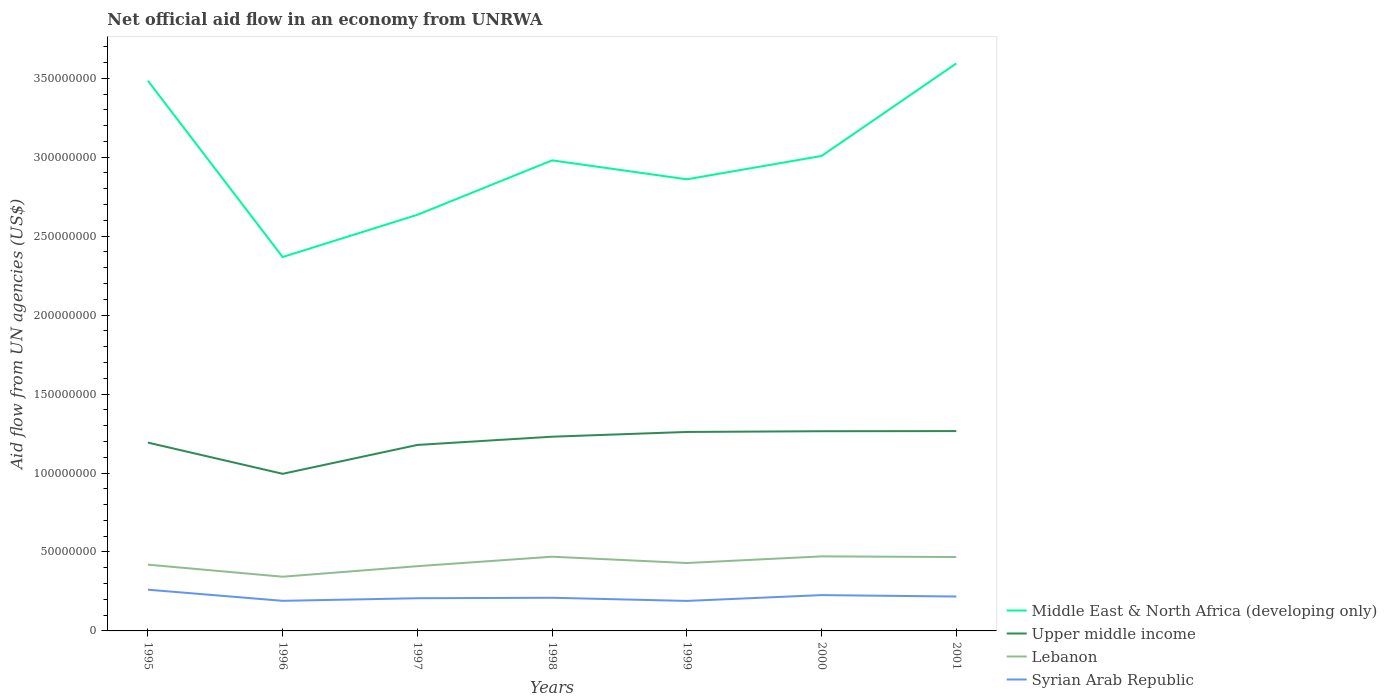How many different coloured lines are there?
Make the answer very short. 4. Across all years, what is the maximum net official aid flow in Syrian Arab Republic?
Make the answer very short. 1.90e+07. What is the total net official aid flow in Middle East & North Africa (developing only) in the graph?
Provide a short and direct response. -6.14e+07. What is the difference between the highest and the second highest net official aid flow in Lebanon?
Offer a very short reply. 1.29e+07. How many lines are there?
Provide a short and direct response. 4. Are the values on the major ticks of Y-axis written in scientific E-notation?
Ensure brevity in your answer.  No. Does the graph contain any zero values?
Give a very brief answer. No. How are the legend labels stacked?
Make the answer very short. Vertical. What is the title of the graph?
Your answer should be very brief. Net official aid flow in an economy from UNRWA. Does "Nepal" appear as one of the legend labels in the graph?
Your answer should be very brief. No. What is the label or title of the Y-axis?
Offer a terse response. Aid flow from UN agencies (US$). What is the Aid flow from UN agencies (US$) in Middle East & North Africa (developing only) in 1995?
Your answer should be very brief. 3.48e+08. What is the Aid flow from UN agencies (US$) of Upper middle income in 1995?
Ensure brevity in your answer.  1.19e+08. What is the Aid flow from UN agencies (US$) of Lebanon in 1995?
Offer a terse response. 4.20e+07. What is the Aid flow from UN agencies (US$) in Syrian Arab Republic in 1995?
Offer a terse response. 2.61e+07. What is the Aid flow from UN agencies (US$) of Middle East & North Africa (developing only) in 1996?
Your response must be concise. 2.37e+08. What is the Aid flow from UN agencies (US$) in Upper middle income in 1996?
Provide a succinct answer. 9.95e+07. What is the Aid flow from UN agencies (US$) of Lebanon in 1996?
Your answer should be compact. 3.43e+07. What is the Aid flow from UN agencies (US$) in Syrian Arab Republic in 1996?
Your response must be concise. 1.91e+07. What is the Aid flow from UN agencies (US$) of Middle East & North Africa (developing only) in 1997?
Your response must be concise. 2.64e+08. What is the Aid flow from UN agencies (US$) in Upper middle income in 1997?
Offer a very short reply. 1.18e+08. What is the Aid flow from UN agencies (US$) in Lebanon in 1997?
Provide a succinct answer. 4.10e+07. What is the Aid flow from UN agencies (US$) of Syrian Arab Republic in 1997?
Give a very brief answer. 2.07e+07. What is the Aid flow from UN agencies (US$) in Middle East & North Africa (developing only) in 1998?
Your response must be concise. 2.98e+08. What is the Aid flow from UN agencies (US$) of Upper middle income in 1998?
Make the answer very short. 1.23e+08. What is the Aid flow from UN agencies (US$) in Lebanon in 1998?
Your answer should be very brief. 4.70e+07. What is the Aid flow from UN agencies (US$) of Syrian Arab Republic in 1998?
Ensure brevity in your answer.  2.10e+07. What is the Aid flow from UN agencies (US$) of Middle East & North Africa (developing only) in 1999?
Give a very brief answer. 2.86e+08. What is the Aid flow from UN agencies (US$) in Upper middle income in 1999?
Offer a terse response. 1.26e+08. What is the Aid flow from UN agencies (US$) of Lebanon in 1999?
Make the answer very short. 4.30e+07. What is the Aid flow from UN agencies (US$) of Syrian Arab Republic in 1999?
Offer a terse response. 1.90e+07. What is the Aid flow from UN agencies (US$) of Middle East & North Africa (developing only) in 2000?
Your response must be concise. 3.01e+08. What is the Aid flow from UN agencies (US$) of Upper middle income in 2000?
Ensure brevity in your answer.  1.26e+08. What is the Aid flow from UN agencies (US$) in Lebanon in 2000?
Your answer should be compact. 4.72e+07. What is the Aid flow from UN agencies (US$) in Syrian Arab Republic in 2000?
Give a very brief answer. 2.27e+07. What is the Aid flow from UN agencies (US$) of Middle East & North Africa (developing only) in 2001?
Ensure brevity in your answer.  3.59e+08. What is the Aid flow from UN agencies (US$) of Upper middle income in 2001?
Your answer should be compact. 1.27e+08. What is the Aid flow from UN agencies (US$) of Lebanon in 2001?
Make the answer very short. 4.68e+07. What is the Aid flow from UN agencies (US$) in Syrian Arab Republic in 2001?
Offer a terse response. 2.18e+07. Across all years, what is the maximum Aid flow from UN agencies (US$) of Middle East & North Africa (developing only)?
Your response must be concise. 3.59e+08. Across all years, what is the maximum Aid flow from UN agencies (US$) in Upper middle income?
Make the answer very short. 1.27e+08. Across all years, what is the maximum Aid flow from UN agencies (US$) of Lebanon?
Provide a succinct answer. 4.72e+07. Across all years, what is the maximum Aid flow from UN agencies (US$) in Syrian Arab Republic?
Your response must be concise. 2.61e+07. Across all years, what is the minimum Aid flow from UN agencies (US$) in Middle East & North Africa (developing only)?
Offer a terse response. 2.37e+08. Across all years, what is the minimum Aid flow from UN agencies (US$) in Upper middle income?
Offer a very short reply. 9.95e+07. Across all years, what is the minimum Aid flow from UN agencies (US$) in Lebanon?
Your answer should be compact. 3.43e+07. Across all years, what is the minimum Aid flow from UN agencies (US$) of Syrian Arab Republic?
Provide a short and direct response. 1.90e+07. What is the total Aid flow from UN agencies (US$) in Middle East & North Africa (developing only) in the graph?
Your answer should be very brief. 2.09e+09. What is the total Aid flow from UN agencies (US$) in Upper middle income in the graph?
Your response must be concise. 8.39e+08. What is the total Aid flow from UN agencies (US$) of Lebanon in the graph?
Provide a short and direct response. 3.01e+08. What is the total Aid flow from UN agencies (US$) in Syrian Arab Republic in the graph?
Your answer should be very brief. 1.50e+08. What is the difference between the Aid flow from UN agencies (US$) in Middle East & North Africa (developing only) in 1995 and that in 1996?
Your answer should be very brief. 1.12e+08. What is the difference between the Aid flow from UN agencies (US$) of Upper middle income in 1995 and that in 1996?
Your answer should be very brief. 1.98e+07. What is the difference between the Aid flow from UN agencies (US$) of Lebanon in 1995 and that in 1996?
Your response must be concise. 7.63e+06. What is the difference between the Aid flow from UN agencies (US$) of Syrian Arab Republic in 1995 and that in 1996?
Provide a succinct answer. 7.05e+06. What is the difference between the Aid flow from UN agencies (US$) in Middle East & North Africa (developing only) in 1995 and that in 1997?
Offer a very short reply. 8.49e+07. What is the difference between the Aid flow from UN agencies (US$) of Upper middle income in 1995 and that in 1997?
Keep it short and to the point. 1.48e+06. What is the difference between the Aid flow from UN agencies (US$) in Lebanon in 1995 and that in 1997?
Provide a succinct answer. 9.60e+05. What is the difference between the Aid flow from UN agencies (US$) in Syrian Arab Republic in 1995 and that in 1997?
Provide a short and direct response. 5.41e+06. What is the difference between the Aid flow from UN agencies (US$) of Middle East & North Africa (developing only) in 1995 and that in 1998?
Your answer should be compact. 5.04e+07. What is the difference between the Aid flow from UN agencies (US$) in Upper middle income in 1995 and that in 1998?
Make the answer very short. -3.74e+06. What is the difference between the Aid flow from UN agencies (US$) of Lebanon in 1995 and that in 1998?
Provide a short and direct response. -5.04e+06. What is the difference between the Aid flow from UN agencies (US$) in Syrian Arab Republic in 1995 and that in 1998?
Your answer should be very brief. 5.11e+06. What is the difference between the Aid flow from UN agencies (US$) in Middle East & North Africa (developing only) in 1995 and that in 1999?
Your answer should be compact. 6.24e+07. What is the difference between the Aid flow from UN agencies (US$) of Upper middle income in 1995 and that in 1999?
Keep it short and to the point. -6.74e+06. What is the difference between the Aid flow from UN agencies (US$) in Lebanon in 1995 and that in 1999?
Your answer should be compact. -1.04e+06. What is the difference between the Aid flow from UN agencies (US$) of Syrian Arab Republic in 1995 and that in 1999?
Provide a short and direct response. 7.11e+06. What is the difference between the Aid flow from UN agencies (US$) in Middle East & North Africa (developing only) in 1995 and that in 2000?
Provide a short and direct response. 4.76e+07. What is the difference between the Aid flow from UN agencies (US$) of Upper middle income in 1995 and that in 2000?
Ensure brevity in your answer.  -7.21e+06. What is the difference between the Aid flow from UN agencies (US$) of Lebanon in 1995 and that in 2000?
Provide a short and direct response. -5.25e+06. What is the difference between the Aid flow from UN agencies (US$) in Syrian Arab Republic in 1995 and that in 2000?
Provide a succinct answer. 3.43e+06. What is the difference between the Aid flow from UN agencies (US$) of Middle East & North Africa (developing only) in 1995 and that in 2001?
Offer a very short reply. -1.10e+07. What is the difference between the Aid flow from UN agencies (US$) of Upper middle income in 1995 and that in 2001?
Keep it short and to the point. -7.30e+06. What is the difference between the Aid flow from UN agencies (US$) of Lebanon in 1995 and that in 2001?
Provide a short and direct response. -4.83e+06. What is the difference between the Aid flow from UN agencies (US$) in Syrian Arab Republic in 1995 and that in 2001?
Offer a very short reply. 4.33e+06. What is the difference between the Aid flow from UN agencies (US$) in Middle East & North Africa (developing only) in 1996 and that in 1997?
Provide a succinct answer. -2.67e+07. What is the difference between the Aid flow from UN agencies (US$) in Upper middle income in 1996 and that in 1997?
Your response must be concise. -1.83e+07. What is the difference between the Aid flow from UN agencies (US$) in Lebanon in 1996 and that in 1997?
Your response must be concise. -6.67e+06. What is the difference between the Aid flow from UN agencies (US$) of Syrian Arab Republic in 1996 and that in 1997?
Your answer should be compact. -1.64e+06. What is the difference between the Aid flow from UN agencies (US$) of Middle East & North Africa (developing only) in 1996 and that in 1998?
Your answer should be very brief. -6.12e+07. What is the difference between the Aid flow from UN agencies (US$) in Upper middle income in 1996 and that in 1998?
Provide a succinct answer. -2.35e+07. What is the difference between the Aid flow from UN agencies (US$) of Lebanon in 1996 and that in 1998?
Give a very brief answer. -1.27e+07. What is the difference between the Aid flow from UN agencies (US$) in Syrian Arab Republic in 1996 and that in 1998?
Provide a succinct answer. -1.94e+06. What is the difference between the Aid flow from UN agencies (US$) in Middle East & North Africa (developing only) in 1996 and that in 1999?
Offer a very short reply. -4.92e+07. What is the difference between the Aid flow from UN agencies (US$) in Upper middle income in 1996 and that in 1999?
Keep it short and to the point. -2.65e+07. What is the difference between the Aid flow from UN agencies (US$) of Lebanon in 1996 and that in 1999?
Offer a terse response. -8.67e+06. What is the difference between the Aid flow from UN agencies (US$) in Middle East & North Africa (developing only) in 1996 and that in 2000?
Your answer should be compact. -6.40e+07. What is the difference between the Aid flow from UN agencies (US$) in Upper middle income in 1996 and that in 2000?
Offer a terse response. -2.70e+07. What is the difference between the Aid flow from UN agencies (US$) in Lebanon in 1996 and that in 2000?
Ensure brevity in your answer.  -1.29e+07. What is the difference between the Aid flow from UN agencies (US$) of Syrian Arab Republic in 1996 and that in 2000?
Your response must be concise. -3.62e+06. What is the difference between the Aid flow from UN agencies (US$) in Middle East & North Africa (developing only) in 1996 and that in 2001?
Your response must be concise. -1.23e+08. What is the difference between the Aid flow from UN agencies (US$) in Upper middle income in 1996 and that in 2001?
Provide a succinct answer. -2.71e+07. What is the difference between the Aid flow from UN agencies (US$) in Lebanon in 1996 and that in 2001?
Your answer should be very brief. -1.25e+07. What is the difference between the Aid flow from UN agencies (US$) in Syrian Arab Republic in 1996 and that in 2001?
Provide a short and direct response. -2.72e+06. What is the difference between the Aid flow from UN agencies (US$) in Middle East & North Africa (developing only) in 1997 and that in 1998?
Your response must be concise. -3.45e+07. What is the difference between the Aid flow from UN agencies (US$) in Upper middle income in 1997 and that in 1998?
Provide a succinct answer. -5.22e+06. What is the difference between the Aid flow from UN agencies (US$) in Lebanon in 1997 and that in 1998?
Make the answer very short. -6.00e+06. What is the difference between the Aid flow from UN agencies (US$) of Syrian Arab Republic in 1997 and that in 1998?
Keep it short and to the point. -3.00e+05. What is the difference between the Aid flow from UN agencies (US$) of Middle East & North Africa (developing only) in 1997 and that in 1999?
Provide a succinct answer. -2.25e+07. What is the difference between the Aid flow from UN agencies (US$) of Upper middle income in 1997 and that in 1999?
Your answer should be very brief. -8.22e+06. What is the difference between the Aid flow from UN agencies (US$) of Syrian Arab Republic in 1997 and that in 1999?
Your response must be concise. 1.70e+06. What is the difference between the Aid flow from UN agencies (US$) of Middle East & North Africa (developing only) in 1997 and that in 2000?
Provide a short and direct response. -3.73e+07. What is the difference between the Aid flow from UN agencies (US$) in Upper middle income in 1997 and that in 2000?
Give a very brief answer. -8.69e+06. What is the difference between the Aid flow from UN agencies (US$) in Lebanon in 1997 and that in 2000?
Offer a terse response. -6.21e+06. What is the difference between the Aid flow from UN agencies (US$) in Syrian Arab Republic in 1997 and that in 2000?
Keep it short and to the point. -1.98e+06. What is the difference between the Aid flow from UN agencies (US$) of Middle East & North Africa (developing only) in 1997 and that in 2001?
Provide a succinct answer. -9.58e+07. What is the difference between the Aid flow from UN agencies (US$) in Upper middle income in 1997 and that in 2001?
Keep it short and to the point. -8.78e+06. What is the difference between the Aid flow from UN agencies (US$) of Lebanon in 1997 and that in 2001?
Give a very brief answer. -5.79e+06. What is the difference between the Aid flow from UN agencies (US$) of Syrian Arab Republic in 1997 and that in 2001?
Your answer should be compact. -1.08e+06. What is the difference between the Aid flow from UN agencies (US$) in Lebanon in 1998 and that in 1999?
Provide a succinct answer. 4.00e+06. What is the difference between the Aid flow from UN agencies (US$) in Syrian Arab Republic in 1998 and that in 1999?
Give a very brief answer. 2.00e+06. What is the difference between the Aid flow from UN agencies (US$) of Middle East & North Africa (developing only) in 1998 and that in 2000?
Keep it short and to the point. -2.78e+06. What is the difference between the Aid flow from UN agencies (US$) of Upper middle income in 1998 and that in 2000?
Offer a very short reply. -3.47e+06. What is the difference between the Aid flow from UN agencies (US$) in Lebanon in 1998 and that in 2000?
Your answer should be very brief. -2.10e+05. What is the difference between the Aid flow from UN agencies (US$) of Syrian Arab Republic in 1998 and that in 2000?
Keep it short and to the point. -1.68e+06. What is the difference between the Aid flow from UN agencies (US$) of Middle East & North Africa (developing only) in 1998 and that in 2001?
Ensure brevity in your answer.  -6.14e+07. What is the difference between the Aid flow from UN agencies (US$) of Upper middle income in 1998 and that in 2001?
Offer a terse response. -3.56e+06. What is the difference between the Aid flow from UN agencies (US$) in Lebanon in 1998 and that in 2001?
Your response must be concise. 2.10e+05. What is the difference between the Aid flow from UN agencies (US$) in Syrian Arab Republic in 1998 and that in 2001?
Offer a very short reply. -7.80e+05. What is the difference between the Aid flow from UN agencies (US$) in Middle East & North Africa (developing only) in 1999 and that in 2000?
Make the answer very short. -1.48e+07. What is the difference between the Aid flow from UN agencies (US$) in Upper middle income in 1999 and that in 2000?
Offer a terse response. -4.70e+05. What is the difference between the Aid flow from UN agencies (US$) of Lebanon in 1999 and that in 2000?
Your answer should be compact. -4.21e+06. What is the difference between the Aid flow from UN agencies (US$) in Syrian Arab Republic in 1999 and that in 2000?
Give a very brief answer. -3.68e+06. What is the difference between the Aid flow from UN agencies (US$) in Middle East & North Africa (developing only) in 1999 and that in 2001?
Your answer should be compact. -7.34e+07. What is the difference between the Aid flow from UN agencies (US$) in Upper middle income in 1999 and that in 2001?
Provide a short and direct response. -5.60e+05. What is the difference between the Aid flow from UN agencies (US$) of Lebanon in 1999 and that in 2001?
Your response must be concise. -3.79e+06. What is the difference between the Aid flow from UN agencies (US$) in Syrian Arab Republic in 1999 and that in 2001?
Make the answer very short. -2.78e+06. What is the difference between the Aid flow from UN agencies (US$) of Middle East & North Africa (developing only) in 2000 and that in 2001?
Offer a terse response. -5.86e+07. What is the difference between the Aid flow from UN agencies (US$) in Syrian Arab Republic in 2000 and that in 2001?
Provide a succinct answer. 9.00e+05. What is the difference between the Aid flow from UN agencies (US$) of Middle East & North Africa (developing only) in 1995 and the Aid flow from UN agencies (US$) of Upper middle income in 1996?
Your answer should be compact. 2.49e+08. What is the difference between the Aid flow from UN agencies (US$) in Middle East & North Africa (developing only) in 1995 and the Aid flow from UN agencies (US$) in Lebanon in 1996?
Make the answer very short. 3.14e+08. What is the difference between the Aid flow from UN agencies (US$) of Middle East & North Africa (developing only) in 1995 and the Aid flow from UN agencies (US$) of Syrian Arab Republic in 1996?
Your response must be concise. 3.29e+08. What is the difference between the Aid flow from UN agencies (US$) of Upper middle income in 1995 and the Aid flow from UN agencies (US$) of Lebanon in 1996?
Make the answer very short. 8.49e+07. What is the difference between the Aid flow from UN agencies (US$) in Upper middle income in 1995 and the Aid flow from UN agencies (US$) in Syrian Arab Republic in 1996?
Offer a very short reply. 1.00e+08. What is the difference between the Aid flow from UN agencies (US$) of Lebanon in 1995 and the Aid flow from UN agencies (US$) of Syrian Arab Republic in 1996?
Ensure brevity in your answer.  2.29e+07. What is the difference between the Aid flow from UN agencies (US$) in Middle East & North Africa (developing only) in 1995 and the Aid flow from UN agencies (US$) in Upper middle income in 1997?
Provide a succinct answer. 2.31e+08. What is the difference between the Aid flow from UN agencies (US$) of Middle East & North Africa (developing only) in 1995 and the Aid flow from UN agencies (US$) of Lebanon in 1997?
Offer a terse response. 3.07e+08. What is the difference between the Aid flow from UN agencies (US$) of Middle East & North Africa (developing only) in 1995 and the Aid flow from UN agencies (US$) of Syrian Arab Republic in 1997?
Your response must be concise. 3.28e+08. What is the difference between the Aid flow from UN agencies (US$) in Upper middle income in 1995 and the Aid flow from UN agencies (US$) in Lebanon in 1997?
Provide a succinct answer. 7.83e+07. What is the difference between the Aid flow from UN agencies (US$) of Upper middle income in 1995 and the Aid flow from UN agencies (US$) of Syrian Arab Republic in 1997?
Your answer should be very brief. 9.86e+07. What is the difference between the Aid flow from UN agencies (US$) in Lebanon in 1995 and the Aid flow from UN agencies (US$) in Syrian Arab Republic in 1997?
Offer a very short reply. 2.13e+07. What is the difference between the Aid flow from UN agencies (US$) of Middle East & North Africa (developing only) in 1995 and the Aid flow from UN agencies (US$) of Upper middle income in 1998?
Your answer should be very brief. 2.25e+08. What is the difference between the Aid flow from UN agencies (US$) of Middle East & North Africa (developing only) in 1995 and the Aid flow from UN agencies (US$) of Lebanon in 1998?
Your response must be concise. 3.01e+08. What is the difference between the Aid flow from UN agencies (US$) in Middle East & North Africa (developing only) in 1995 and the Aid flow from UN agencies (US$) in Syrian Arab Republic in 1998?
Keep it short and to the point. 3.27e+08. What is the difference between the Aid flow from UN agencies (US$) in Upper middle income in 1995 and the Aid flow from UN agencies (US$) in Lebanon in 1998?
Keep it short and to the point. 7.23e+07. What is the difference between the Aid flow from UN agencies (US$) in Upper middle income in 1995 and the Aid flow from UN agencies (US$) in Syrian Arab Republic in 1998?
Ensure brevity in your answer.  9.83e+07. What is the difference between the Aid flow from UN agencies (US$) in Lebanon in 1995 and the Aid flow from UN agencies (US$) in Syrian Arab Republic in 1998?
Offer a terse response. 2.10e+07. What is the difference between the Aid flow from UN agencies (US$) in Middle East & North Africa (developing only) in 1995 and the Aid flow from UN agencies (US$) in Upper middle income in 1999?
Provide a succinct answer. 2.22e+08. What is the difference between the Aid flow from UN agencies (US$) in Middle East & North Africa (developing only) in 1995 and the Aid flow from UN agencies (US$) in Lebanon in 1999?
Your response must be concise. 3.05e+08. What is the difference between the Aid flow from UN agencies (US$) of Middle East & North Africa (developing only) in 1995 and the Aid flow from UN agencies (US$) of Syrian Arab Republic in 1999?
Provide a short and direct response. 3.29e+08. What is the difference between the Aid flow from UN agencies (US$) of Upper middle income in 1995 and the Aid flow from UN agencies (US$) of Lebanon in 1999?
Give a very brief answer. 7.63e+07. What is the difference between the Aid flow from UN agencies (US$) in Upper middle income in 1995 and the Aid flow from UN agencies (US$) in Syrian Arab Republic in 1999?
Provide a short and direct response. 1.00e+08. What is the difference between the Aid flow from UN agencies (US$) of Lebanon in 1995 and the Aid flow from UN agencies (US$) of Syrian Arab Republic in 1999?
Your answer should be compact. 2.30e+07. What is the difference between the Aid flow from UN agencies (US$) of Middle East & North Africa (developing only) in 1995 and the Aid flow from UN agencies (US$) of Upper middle income in 2000?
Give a very brief answer. 2.22e+08. What is the difference between the Aid flow from UN agencies (US$) in Middle East & North Africa (developing only) in 1995 and the Aid flow from UN agencies (US$) in Lebanon in 2000?
Offer a terse response. 3.01e+08. What is the difference between the Aid flow from UN agencies (US$) of Middle East & North Africa (developing only) in 1995 and the Aid flow from UN agencies (US$) of Syrian Arab Republic in 2000?
Ensure brevity in your answer.  3.26e+08. What is the difference between the Aid flow from UN agencies (US$) in Upper middle income in 1995 and the Aid flow from UN agencies (US$) in Lebanon in 2000?
Offer a terse response. 7.20e+07. What is the difference between the Aid flow from UN agencies (US$) in Upper middle income in 1995 and the Aid flow from UN agencies (US$) in Syrian Arab Republic in 2000?
Your answer should be very brief. 9.66e+07. What is the difference between the Aid flow from UN agencies (US$) in Lebanon in 1995 and the Aid flow from UN agencies (US$) in Syrian Arab Republic in 2000?
Provide a succinct answer. 1.93e+07. What is the difference between the Aid flow from UN agencies (US$) of Middle East & North Africa (developing only) in 1995 and the Aid flow from UN agencies (US$) of Upper middle income in 2001?
Provide a succinct answer. 2.22e+08. What is the difference between the Aid flow from UN agencies (US$) of Middle East & North Africa (developing only) in 1995 and the Aid flow from UN agencies (US$) of Lebanon in 2001?
Ensure brevity in your answer.  3.02e+08. What is the difference between the Aid flow from UN agencies (US$) in Middle East & North Africa (developing only) in 1995 and the Aid flow from UN agencies (US$) in Syrian Arab Republic in 2001?
Provide a succinct answer. 3.27e+08. What is the difference between the Aid flow from UN agencies (US$) of Upper middle income in 1995 and the Aid flow from UN agencies (US$) of Lebanon in 2001?
Make the answer very short. 7.25e+07. What is the difference between the Aid flow from UN agencies (US$) of Upper middle income in 1995 and the Aid flow from UN agencies (US$) of Syrian Arab Republic in 2001?
Your answer should be very brief. 9.75e+07. What is the difference between the Aid flow from UN agencies (US$) in Lebanon in 1995 and the Aid flow from UN agencies (US$) in Syrian Arab Republic in 2001?
Provide a succinct answer. 2.02e+07. What is the difference between the Aid flow from UN agencies (US$) in Middle East & North Africa (developing only) in 1996 and the Aid flow from UN agencies (US$) in Upper middle income in 1997?
Keep it short and to the point. 1.19e+08. What is the difference between the Aid flow from UN agencies (US$) in Middle East & North Africa (developing only) in 1996 and the Aid flow from UN agencies (US$) in Lebanon in 1997?
Provide a short and direct response. 1.96e+08. What is the difference between the Aid flow from UN agencies (US$) of Middle East & North Africa (developing only) in 1996 and the Aid flow from UN agencies (US$) of Syrian Arab Republic in 1997?
Your answer should be compact. 2.16e+08. What is the difference between the Aid flow from UN agencies (US$) in Upper middle income in 1996 and the Aid flow from UN agencies (US$) in Lebanon in 1997?
Provide a succinct answer. 5.85e+07. What is the difference between the Aid flow from UN agencies (US$) of Upper middle income in 1996 and the Aid flow from UN agencies (US$) of Syrian Arab Republic in 1997?
Give a very brief answer. 7.88e+07. What is the difference between the Aid flow from UN agencies (US$) in Lebanon in 1996 and the Aid flow from UN agencies (US$) in Syrian Arab Republic in 1997?
Offer a terse response. 1.36e+07. What is the difference between the Aid flow from UN agencies (US$) of Middle East & North Africa (developing only) in 1996 and the Aid flow from UN agencies (US$) of Upper middle income in 1998?
Keep it short and to the point. 1.14e+08. What is the difference between the Aid flow from UN agencies (US$) of Middle East & North Africa (developing only) in 1996 and the Aid flow from UN agencies (US$) of Lebanon in 1998?
Offer a terse response. 1.90e+08. What is the difference between the Aid flow from UN agencies (US$) of Middle East & North Africa (developing only) in 1996 and the Aid flow from UN agencies (US$) of Syrian Arab Republic in 1998?
Your answer should be compact. 2.16e+08. What is the difference between the Aid flow from UN agencies (US$) of Upper middle income in 1996 and the Aid flow from UN agencies (US$) of Lebanon in 1998?
Ensure brevity in your answer.  5.25e+07. What is the difference between the Aid flow from UN agencies (US$) of Upper middle income in 1996 and the Aid flow from UN agencies (US$) of Syrian Arab Republic in 1998?
Your answer should be very brief. 7.85e+07. What is the difference between the Aid flow from UN agencies (US$) in Lebanon in 1996 and the Aid flow from UN agencies (US$) in Syrian Arab Republic in 1998?
Your response must be concise. 1.33e+07. What is the difference between the Aid flow from UN agencies (US$) of Middle East & North Africa (developing only) in 1996 and the Aid flow from UN agencies (US$) of Upper middle income in 1999?
Keep it short and to the point. 1.11e+08. What is the difference between the Aid flow from UN agencies (US$) of Middle East & North Africa (developing only) in 1996 and the Aid flow from UN agencies (US$) of Lebanon in 1999?
Your answer should be compact. 1.94e+08. What is the difference between the Aid flow from UN agencies (US$) in Middle East & North Africa (developing only) in 1996 and the Aid flow from UN agencies (US$) in Syrian Arab Republic in 1999?
Provide a succinct answer. 2.18e+08. What is the difference between the Aid flow from UN agencies (US$) in Upper middle income in 1996 and the Aid flow from UN agencies (US$) in Lebanon in 1999?
Keep it short and to the point. 5.65e+07. What is the difference between the Aid flow from UN agencies (US$) in Upper middle income in 1996 and the Aid flow from UN agencies (US$) in Syrian Arab Republic in 1999?
Give a very brief answer. 8.05e+07. What is the difference between the Aid flow from UN agencies (US$) of Lebanon in 1996 and the Aid flow from UN agencies (US$) of Syrian Arab Republic in 1999?
Ensure brevity in your answer.  1.53e+07. What is the difference between the Aid flow from UN agencies (US$) in Middle East & North Africa (developing only) in 1996 and the Aid flow from UN agencies (US$) in Upper middle income in 2000?
Give a very brief answer. 1.10e+08. What is the difference between the Aid flow from UN agencies (US$) of Middle East & North Africa (developing only) in 1996 and the Aid flow from UN agencies (US$) of Lebanon in 2000?
Keep it short and to the point. 1.90e+08. What is the difference between the Aid flow from UN agencies (US$) of Middle East & North Africa (developing only) in 1996 and the Aid flow from UN agencies (US$) of Syrian Arab Republic in 2000?
Your response must be concise. 2.14e+08. What is the difference between the Aid flow from UN agencies (US$) of Upper middle income in 1996 and the Aid flow from UN agencies (US$) of Lebanon in 2000?
Your answer should be very brief. 5.23e+07. What is the difference between the Aid flow from UN agencies (US$) in Upper middle income in 1996 and the Aid flow from UN agencies (US$) in Syrian Arab Republic in 2000?
Your answer should be compact. 7.68e+07. What is the difference between the Aid flow from UN agencies (US$) of Lebanon in 1996 and the Aid flow from UN agencies (US$) of Syrian Arab Republic in 2000?
Provide a succinct answer. 1.16e+07. What is the difference between the Aid flow from UN agencies (US$) in Middle East & North Africa (developing only) in 1996 and the Aid flow from UN agencies (US$) in Upper middle income in 2001?
Your response must be concise. 1.10e+08. What is the difference between the Aid flow from UN agencies (US$) of Middle East & North Africa (developing only) in 1996 and the Aid flow from UN agencies (US$) of Lebanon in 2001?
Offer a terse response. 1.90e+08. What is the difference between the Aid flow from UN agencies (US$) of Middle East & North Africa (developing only) in 1996 and the Aid flow from UN agencies (US$) of Syrian Arab Republic in 2001?
Keep it short and to the point. 2.15e+08. What is the difference between the Aid flow from UN agencies (US$) in Upper middle income in 1996 and the Aid flow from UN agencies (US$) in Lebanon in 2001?
Your response must be concise. 5.27e+07. What is the difference between the Aid flow from UN agencies (US$) in Upper middle income in 1996 and the Aid flow from UN agencies (US$) in Syrian Arab Republic in 2001?
Offer a very short reply. 7.77e+07. What is the difference between the Aid flow from UN agencies (US$) in Lebanon in 1996 and the Aid flow from UN agencies (US$) in Syrian Arab Republic in 2001?
Provide a succinct answer. 1.26e+07. What is the difference between the Aid flow from UN agencies (US$) in Middle East & North Africa (developing only) in 1997 and the Aid flow from UN agencies (US$) in Upper middle income in 1998?
Your answer should be compact. 1.41e+08. What is the difference between the Aid flow from UN agencies (US$) of Middle East & North Africa (developing only) in 1997 and the Aid flow from UN agencies (US$) of Lebanon in 1998?
Give a very brief answer. 2.17e+08. What is the difference between the Aid flow from UN agencies (US$) of Middle East & North Africa (developing only) in 1997 and the Aid flow from UN agencies (US$) of Syrian Arab Republic in 1998?
Your answer should be compact. 2.43e+08. What is the difference between the Aid flow from UN agencies (US$) in Upper middle income in 1997 and the Aid flow from UN agencies (US$) in Lebanon in 1998?
Give a very brief answer. 7.08e+07. What is the difference between the Aid flow from UN agencies (US$) in Upper middle income in 1997 and the Aid flow from UN agencies (US$) in Syrian Arab Republic in 1998?
Your answer should be compact. 9.68e+07. What is the difference between the Aid flow from UN agencies (US$) of Lebanon in 1997 and the Aid flow from UN agencies (US$) of Syrian Arab Republic in 1998?
Your answer should be compact. 2.00e+07. What is the difference between the Aid flow from UN agencies (US$) of Middle East & North Africa (developing only) in 1997 and the Aid flow from UN agencies (US$) of Upper middle income in 1999?
Make the answer very short. 1.38e+08. What is the difference between the Aid flow from UN agencies (US$) of Middle East & North Africa (developing only) in 1997 and the Aid flow from UN agencies (US$) of Lebanon in 1999?
Ensure brevity in your answer.  2.21e+08. What is the difference between the Aid flow from UN agencies (US$) in Middle East & North Africa (developing only) in 1997 and the Aid flow from UN agencies (US$) in Syrian Arab Republic in 1999?
Your answer should be very brief. 2.45e+08. What is the difference between the Aid flow from UN agencies (US$) in Upper middle income in 1997 and the Aid flow from UN agencies (US$) in Lebanon in 1999?
Your response must be concise. 7.48e+07. What is the difference between the Aid flow from UN agencies (US$) of Upper middle income in 1997 and the Aid flow from UN agencies (US$) of Syrian Arab Republic in 1999?
Offer a very short reply. 9.88e+07. What is the difference between the Aid flow from UN agencies (US$) of Lebanon in 1997 and the Aid flow from UN agencies (US$) of Syrian Arab Republic in 1999?
Make the answer very short. 2.20e+07. What is the difference between the Aid flow from UN agencies (US$) of Middle East & North Africa (developing only) in 1997 and the Aid flow from UN agencies (US$) of Upper middle income in 2000?
Provide a short and direct response. 1.37e+08. What is the difference between the Aid flow from UN agencies (US$) of Middle East & North Africa (developing only) in 1997 and the Aid flow from UN agencies (US$) of Lebanon in 2000?
Keep it short and to the point. 2.16e+08. What is the difference between the Aid flow from UN agencies (US$) in Middle East & North Africa (developing only) in 1997 and the Aid flow from UN agencies (US$) in Syrian Arab Republic in 2000?
Offer a very short reply. 2.41e+08. What is the difference between the Aid flow from UN agencies (US$) of Upper middle income in 1997 and the Aid flow from UN agencies (US$) of Lebanon in 2000?
Give a very brief answer. 7.06e+07. What is the difference between the Aid flow from UN agencies (US$) of Upper middle income in 1997 and the Aid flow from UN agencies (US$) of Syrian Arab Republic in 2000?
Your answer should be compact. 9.51e+07. What is the difference between the Aid flow from UN agencies (US$) of Lebanon in 1997 and the Aid flow from UN agencies (US$) of Syrian Arab Republic in 2000?
Your response must be concise. 1.83e+07. What is the difference between the Aid flow from UN agencies (US$) in Middle East & North Africa (developing only) in 1997 and the Aid flow from UN agencies (US$) in Upper middle income in 2001?
Offer a very short reply. 1.37e+08. What is the difference between the Aid flow from UN agencies (US$) in Middle East & North Africa (developing only) in 1997 and the Aid flow from UN agencies (US$) in Lebanon in 2001?
Keep it short and to the point. 2.17e+08. What is the difference between the Aid flow from UN agencies (US$) in Middle East & North Africa (developing only) in 1997 and the Aid flow from UN agencies (US$) in Syrian Arab Republic in 2001?
Keep it short and to the point. 2.42e+08. What is the difference between the Aid flow from UN agencies (US$) in Upper middle income in 1997 and the Aid flow from UN agencies (US$) in Lebanon in 2001?
Offer a terse response. 7.10e+07. What is the difference between the Aid flow from UN agencies (US$) of Upper middle income in 1997 and the Aid flow from UN agencies (US$) of Syrian Arab Republic in 2001?
Offer a very short reply. 9.60e+07. What is the difference between the Aid flow from UN agencies (US$) of Lebanon in 1997 and the Aid flow from UN agencies (US$) of Syrian Arab Republic in 2001?
Make the answer very short. 1.92e+07. What is the difference between the Aid flow from UN agencies (US$) in Middle East & North Africa (developing only) in 1998 and the Aid flow from UN agencies (US$) in Upper middle income in 1999?
Offer a terse response. 1.72e+08. What is the difference between the Aid flow from UN agencies (US$) of Middle East & North Africa (developing only) in 1998 and the Aid flow from UN agencies (US$) of Lebanon in 1999?
Your answer should be very brief. 2.55e+08. What is the difference between the Aid flow from UN agencies (US$) in Middle East & North Africa (developing only) in 1998 and the Aid flow from UN agencies (US$) in Syrian Arab Republic in 1999?
Provide a succinct answer. 2.79e+08. What is the difference between the Aid flow from UN agencies (US$) of Upper middle income in 1998 and the Aid flow from UN agencies (US$) of Lebanon in 1999?
Your response must be concise. 8.00e+07. What is the difference between the Aid flow from UN agencies (US$) of Upper middle income in 1998 and the Aid flow from UN agencies (US$) of Syrian Arab Republic in 1999?
Your response must be concise. 1.04e+08. What is the difference between the Aid flow from UN agencies (US$) in Lebanon in 1998 and the Aid flow from UN agencies (US$) in Syrian Arab Republic in 1999?
Provide a short and direct response. 2.80e+07. What is the difference between the Aid flow from UN agencies (US$) in Middle East & North Africa (developing only) in 1998 and the Aid flow from UN agencies (US$) in Upper middle income in 2000?
Ensure brevity in your answer.  1.72e+08. What is the difference between the Aid flow from UN agencies (US$) of Middle East & North Africa (developing only) in 1998 and the Aid flow from UN agencies (US$) of Lebanon in 2000?
Give a very brief answer. 2.51e+08. What is the difference between the Aid flow from UN agencies (US$) in Middle East & North Africa (developing only) in 1998 and the Aid flow from UN agencies (US$) in Syrian Arab Republic in 2000?
Offer a terse response. 2.75e+08. What is the difference between the Aid flow from UN agencies (US$) of Upper middle income in 1998 and the Aid flow from UN agencies (US$) of Lebanon in 2000?
Your response must be concise. 7.58e+07. What is the difference between the Aid flow from UN agencies (US$) of Upper middle income in 1998 and the Aid flow from UN agencies (US$) of Syrian Arab Republic in 2000?
Offer a terse response. 1.00e+08. What is the difference between the Aid flow from UN agencies (US$) in Lebanon in 1998 and the Aid flow from UN agencies (US$) in Syrian Arab Republic in 2000?
Give a very brief answer. 2.43e+07. What is the difference between the Aid flow from UN agencies (US$) in Middle East & North Africa (developing only) in 1998 and the Aid flow from UN agencies (US$) in Upper middle income in 2001?
Your answer should be compact. 1.71e+08. What is the difference between the Aid flow from UN agencies (US$) in Middle East & North Africa (developing only) in 1998 and the Aid flow from UN agencies (US$) in Lebanon in 2001?
Your answer should be very brief. 2.51e+08. What is the difference between the Aid flow from UN agencies (US$) of Middle East & North Africa (developing only) in 1998 and the Aid flow from UN agencies (US$) of Syrian Arab Republic in 2001?
Provide a short and direct response. 2.76e+08. What is the difference between the Aid flow from UN agencies (US$) in Upper middle income in 1998 and the Aid flow from UN agencies (US$) in Lebanon in 2001?
Your answer should be compact. 7.62e+07. What is the difference between the Aid flow from UN agencies (US$) of Upper middle income in 1998 and the Aid flow from UN agencies (US$) of Syrian Arab Republic in 2001?
Your answer should be very brief. 1.01e+08. What is the difference between the Aid flow from UN agencies (US$) in Lebanon in 1998 and the Aid flow from UN agencies (US$) in Syrian Arab Republic in 2001?
Keep it short and to the point. 2.52e+07. What is the difference between the Aid flow from UN agencies (US$) of Middle East & North Africa (developing only) in 1999 and the Aid flow from UN agencies (US$) of Upper middle income in 2000?
Your answer should be compact. 1.60e+08. What is the difference between the Aid flow from UN agencies (US$) in Middle East & North Africa (developing only) in 1999 and the Aid flow from UN agencies (US$) in Lebanon in 2000?
Give a very brief answer. 2.39e+08. What is the difference between the Aid flow from UN agencies (US$) in Middle East & North Africa (developing only) in 1999 and the Aid flow from UN agencies (US$) in Syrian Arab Republic in 2000?
Make the answer very short. 2.63e+08. What is the difference between the Aid flow from UN agencies (US$) of Upper middle income in 1999 and the Aid flow from UN agencies (US$) of Lebanon in 2000?
Give a very brief answer. 7.88e+07. What is the difference between the Aid flow from UN agencies (US$) in Upper middle income in 1999 and the Aid flow from UN agencies (US$) in Syrian Arab Republic in 2000?
Offer a very short reply. 1.03e+08. What is the difference between the Aid flow from UN agencies (US$) in Lebanon in 1999 and the Aid flow from UN agencies (US$) in Syrian Arab Republic in 2000?
Your answer should be very brief. 2.03e+07. What is the difference between the Aid flow from UN agencies (US$) of Middle East & North Africa (developing only) in 1999 and the Aid flow from UN agencies (US$) of Upper middle income in 2001?
Provide a succinct answer. 1.59e+08. What is the difference between the Aid flow from UN agencies (US$) of Middle East & North Africa (developing only) in 1999 and the Aid flow from UN agencies (US$) of Lebanon in 2001?
Provide a succinct answer. 2.39e+08. What is the difference between the Aid flow from UN agencies (US$) of Middle East & North Africa (developing only) in 1999 and the Aid flow from UN agencies (US$) of Syrian Arab Republic in 2001?
Your response must be concise. 2.64e+08. What is the difference between the Aid flow from UN agencies (US$) in Upper middle income in 1999 and the Aid flow from UN agencies (US$) in Lebanon in 2001?
Offer a terse response. 7.92e+07. What is the difference between the Aid flow from UN agencies (US$) of Upper middle income in 1999 and the Aid flow from UN agencies (US$) of Syrian Arab Republic in 2001?
Your answer should be compact. 1.04e+08. What is the difference between the Aid flow from UN agencies (US$) of Lebanon in 1999 and the Aid flow from UN agencies (US$) of Syrian Arab Republic in 2001?
Ensure brevity in your answer.  2.12e+07. What is the difference between the Aid flow from UN agencies (US$) in Middle East & North Africa (developing only) in 2000 and the Aid flow from UN agencies (US$) in Upper middle income in 2001?
Offer a very short reply. 1.74e+08. What is the difference between the Aid flow from UN agencies (US$) in Middle East & North Africa (developing only) in 2000 and the Aid flow from UN agencies (US$) in Lebanon in 2001?
Your answer should be compact. 2.54e+08. What is the difference between the Aid flow from UN agencies (US$) of Middle East & North Africa (developing only) in 2000 and the Aid flow from UN agencies (US$) of Syrian Arab Republic in 2001?
Offer a terse response. 2.79e+08. What is the difference between the Aid flow from UN agencies (US$) in Upper middle income in 2000 and the Aid flow from UN agencies (US$) in Lebanon in 2001?
Offer a terse response. 7.97e+07. What is the difference between the Aid flow from UN agencies (US$) in Upper middle income in 2000 and the Aid flow from UN agencies (US$) in Syrian Arab Republic in 2001?
Your answer should be compact. 1.05e+08. What is the difference between the Aid flow from UN agencies (US$) in Lebanon in 2000 and the Aid flow from UN agencies (US$) in Syrian Arab Republic in 2001?
Your answer should be compact. 2.54e+07. What is the average Aid flow from UN agencies (US$) of Middle East & North Africa (developing only) per year?
Provide a short and direct response. 2.99e+08. What is the average Aid flow from UN agencies (US$) of Upper middle income per year?
Your answer should be very brief. 1.20e+08. What is the average Aid flow from UN agencies (US$) of Lebanon per year?
Offer a very short reply. 4.30e+07. What is the average Aid flow from UN agencies (US$) in Syrian Arab Republic per year?
Keep it short and to the point. 2.15e+07. In the year 1995, what is the difference between the Aid flow from UN agencies (US$) of Middle East & North Africa (developing only) and Aid flow from UN agencies (US$) of Upper middle income?
Keep it short and to the point. 2.29e+08. In the year 1995, what is the difference between the Aid flow from UN agencies (US$) of Middle East & North Africa (developing only) and Aid flow from UN agencies (US$) of Lebanon?
Offer a terse response. 3.06e+08. In the year 1995, what is the difference between the Aid flow from UN agencies (US$) in Middle East & North Africa (developing only) and Aid flow from UN agencies (US$) in Syrian Arab Republic?
Ensure brevity in your answer.  3.22e+08. In the year 1995, what is the difference between the Aid flow from UN agencies (US$) of Upper middle income and Aid flow from UN agencies (US$) of Lebanon?
Give a very brief answer. 7.73e+07. In the year 1995, what is the difference between the Aid flow from UN agencies (US$) in Upper middle income and Aid flow from UN agencies (US$) in Syrian Arab Republic?
Offer a very short reply. 9.32e+07. In the year 1995, what is the difference between the Aid flow from UN agencies (US$) of Lebanon and Aid flow from UN agencies (US$) of Syrian Arab Republic?
Provide a short and direct response. 1.58e+07. In the year 1996, what is the difference between the Aid flow from UN agencies (US$) of Middle East & North Africa (developing only) and Aid flow from UN agencies (US$) of Upper middle income?
Give a very brief answer. 1.37e+08. In the year 1996, what is the difference between the Aid flow from UN agencies (US$) in Middle East & North Africa (developing only) and Aid flow from UN agencies (US$) in Lebanon?
Offer a very short reply. 2.02e+08. In the year 1996, what is the difference between the Aid flow from UN agencies (US$) in Middle East & North Africa (developing only) and Aid flow from UN agencies (US$) in Syrian Arab Republic?
Your answer should be compact. 2.18e+08. In the year 1996, what is the difference between the Aid flow from UN agencies (US$) of Upper middle income and Aid flow from UN agencies (US$) of Lebanon?
Keep it short and to the point. 6.52e+07. In the year 1996, what is the difference between the Aid flow from UN agencies (US$) in Upper middle income and Aid flow from UN agencies (US$) in Syrian Arab Republic?
Keep it short and to the point. 8.04e+07. In the year 1996, what is the difference between the Aid flow from UN agencies (US$) in Lebanon and Aid flow from UN agencies (US$) in Syrian Arab Republic?
Your response must be concise. 1.53e+07. In the year 1997, what is the difference between the Aid flow from UN agencies (US$) of Middle East & North Africa (developing only) and Aid flow from UN agencies (US$) of Upper middle income?
Keep it short and to the point. 1.46e+08. In the year 1997, what is the difference between the Aid flow from UN agencies (US$) in Middle East & North Africa (developing only) and Aid flow from UN agencies (US$) in Lebanon?
Offer a very short reply. 2.23e+08. In the year 1997, what is the difference between the Aid flow from UN agencies (US$) in Middle East & North Africa (developing only) and Aid flow from UN agencies (US$) in Syrian Arab Republic?
Your response must be concise. 2.43e+08. In the year 1997, what is the difference between the Aid flow from UN agencies (US$) of Upper middle income and Aid flow from UN agencies (US$) of Lebanon?
Provide a succinct answer. 7.68e+07. In the year 1997, what is the difference between the Aid flow from UN agencies (US$) of Upper middle income and Aid flow from UN agencies (US$) of Syrian Arab Republic?
Offer a very short reply. 9.71e+07. In the year 1997, what is the difference between the Aid flow from UN agencies (US$) of Lebanon and Aid flow from UN agencies (US$) of Syrian Arab Republic?
Your response must be concise. 2.03e+07. In the year 1998, what is the difference between the Aid flow from UN agencies (US$) of Middle East & North Africa (developing only) and Aid flow from UN agencies (US$) of Upper middle income?
Give a very brief answer. 1.75e+08. In the year 1998, what is the difference between the Aid flow from UN agencies (US$) of Middle East & North Africa (developing only) and Aid flow from UN agencies (US$) of Lebanon?
Keep it short and to the point. 2.51e+08. In the year 1998, what is the difference between the Aid flow from UN agencies (US$) in Middle East & North Africa (developing only) and Aid flow from UN agencies (US$) in Syrian Arab Republic?
Your answer should be compact. 2.77e+08. In the year 1998, what is the difference between the Aid flow from UN agencies (US$) in Upper middle income and Aid flow from UN agencies (US$) in Lebanon?
Keep it short and to the point. 7.60e+07. In the year 1998, what is the difference between the Aid flow from UN agencies (US$) of Upper middle income and Aid flow from UN agencies (US$) of Syrian Arab Republic?
Provide a succinct answer. 1.02e+08. In the year 1998, what is the difference between the Aid flow from UN agencies (US$) of Lebanon and Aid flow from UN agencies (US$) of Syrian Arab Republic?
Provide a short and direct response. 2.60e+07. In the year 1999, what is the difference between the Aid flow from UN agencies (US$) of Middle East & North Africa (developing only) and Aid flow from UN agencies (US$) of Upper middle income?
Give a very brief answer. 1.60e+08. In the year 1999, what is the difference between the Aid flow from UN agencies (US$) of Middle East & North Africa (developing only) and Aid flow from UN agencies (US$) of Lebanon?
Your answer should be compact. 2.43e+08. In the year 1999, what is the difference between the Aid flow from UN agencies (US$) of Middle East & North Africa (developing only) and Aid flow from UN agencies (US$) of Syrian Arab Republic?
Your answer should be compact. 2.67e+08. In the year 1999, what is the difference between the Aid flow from UN agencies (US$) in Upper middle income and Aid flow from UN agencies (US$) in Lebanon?
Ensure brevity in your answer.  8.30e+07. In the year 1999, what is the difference between the Aid flow from UN agencies (US$) of Upper middle income and Aid flow from UN agencies (US$) of Syrian Arab Republic?
Ensure brevity in your answer.  1.07e+08. In the year 1999, what is the difference between the Aid flow from UN agencies (US$) of Lebanon and Aid flow from UN agencies (US$) of Syrian Arab Republic?
Give a very brief answer. 2.40e+07. In the year 2000, what is the difference between the Aid flow from UN agencies (US$) in Middle East & North Africa (developing only) and Aid flow from UN agencies (US$) in Upper middle income?
Offer a terse response. 1.74e+08. In the year 2000, what is the difference between the Aid flow from UN agencies (US$) of Middle East & North Africa (developing only) and Aid flow from UN agencies (US$) of Lebanon?
Give a very brief answer. 2.54e+08. In the year 2000, what is the difference between the Aid flow from UN agencies (US$) in Middle East & North Africa (developing only) and Aid flow from UN agencies (US$) in Syrian Arab Republic?
Give a very brief answer. 2.78e+08. In the year 2000, what is the difference between the Aid flow from UN agencies (US$) in Upper middle income and Aid flow from UN agencies (US$) in Lebanon?
Ensure brevity in your answer.  7.93e+07. In the year 2000, what is the difference between the Aid flow from UN agencies (US$) in Upper middle income and Aid flow from UN agencies (US$) in Syrian Arab Republic?
Offer a very short reply. 1.04e+08. In the year 2000, what is the difference between the Aid flow from UN agencies (US$) in Lebanon and Aid flow from UN agencies (US$) in Syrian Arab Republic?
Your answer should be compact. 2.45e+07. In the year 2001, what is the difference between the Aid flow from UN agencies (US$) in Middle East & North Africa (developing only) and Aid flow from UN agencies (US$) in Upper middle income?
Offer a very short reply. 2.33e+08. In the year 2001, what is the difference between the Aid flow from UN agencies (US$) of Middle East & North Africa (developing only) and Aid flow from UN agencies (US$) of Lebanon?
Give a very brief answer. 3.13e+08. In the year 2001, what is the difference between the Aid flow from UN agencies (US$) in Middle East & North Africa (developing only) and Aid flow from UN agencies (US$) in Syrian Arab Republic?
Your response must be concise. 3.38e+08. In the year 2001, what is the difference between the Aid flow from UN agencies (US$) in Upper middle income and Aid flow from UN agencies (US$) in Lebanon?
Keep it short and to the point. 7.98e+07. In the year 2001, what is the difference between the Aid flow from UN agencies (US$) in Upper middle income and Aid flow from UN agencies (US$) in Syrian Arab Republic?
Provide a short and direct response. 1.05e+08. In the year 2001, what is the difference between the Aid flow from UN agencies (US$) of Lebanon and Aid flow from UN agencies (US$) of Syrian Arab Republic?
Offer a terse response. 2.50e+07. What is the ratio of the Aid flow from UN agencies (US$) in Middle East & North Africa (developing only) in 1995 to that in 1996?
Make the answer very short. 1.47. What is the ratio of the Aid flow from UN agencies (US$) in Upper middle income in 1995 to that in 1996?
Provide a succinct answer. 1.2. What is the ratio of the Aid flow from UN agencies (US$) of Lebanon in 1995 to that in 1996?
Offer a very short reply. 1.22. What is the ratio of the Aid flow from UN agencies (US$) of Syrian Arab Republic in 1995 to that in 1996?
Offer a terse response. 1.37. What is the ratio of the Aid flow from UN agencies (US$) of Middle East & North Africa (developing only) in 1995 to that in 1997?
Give a very brief answer. 1.32. What is the ratio of the Aid flow from UN agencies (US$) in Upper middle income in 1995 to that in 1997?
Give a very brief answer. 1.01. What is the ratio of the Aid flow from UN agencies (US$) in Lebanon in 1995 to that in 1997?
Ensure brevity in your answer.  1.02. What is the ratio of the Aid flow from UN agencies (US$) of Syrian Arab Republic in 1995 to that in 1997?
Keep it short and to the point. 1.26. What is the ratio of the Aid flow from UN agencies (US$) in Middle East & North Africa (developing only) in 1995 to that in 1998?
Provide a succinct answer. 1.17. What is the ratio of the Aid flow from UN agencies (US$) of Upper middle income in 1995 to that in 1998?
Your answer should be compact. 0.97. What is the ratio of the Aid flow from UN agencies (US$) in Lebanon in 1995 to that in 1998?
Offer a very short reply. 0.89. What is the ratio of the Aid flow from UN agencies (US$) in Syrian Arab Republic in 1995 to that in 1998?
Keep it short and to the point. 1.24. What is the ratio of the Aid flow from UN agencies (US$) of Middle East & North Africa (developing only) in 1995 to that in 1999?
Keep it short and to the point. 1.22. What is the ratio of the Aid flow from UN agencies (US$) of Upper middle income in 1995 to that in 1999?
Keep it short and to the point. 0.95. What is the ratio of the Aid flow from UN agencies (US$) of Lebanon in 1995 to that in 1999?
Your answer should be very brief. 0.98. What is the ratio of the Aid flow from UN agencies (US$) in Syrian Arab Republic in 1995 to that in 1999?
Ensure brevity in your answer.  1.37. What is the ratio of the Aid flow from UN agencies (US$) of Middle East & North Africa (developing only) in 1995 to that in 2000?
Offer a terse response. 1.16. What is the ratio of the Aid flow from UN agencies (US$) of Upper middle income in 1995 to that in 2000?
Provide a succinct answer. 0.94. What is the ratio of the Aid flow from UN agencies (US$) of Lebanon in 1995 to that in 2000?
Offer a very short reply. 0.89. What is the ratio of the Aid flow from UN agencies (US$) of Syrian Arab Republic in 1995 to that in 2000?
Keep it short and to the point. 1.15. What is the ratio of the Aid flow from UN agencies (US$) of Middle East & North Africa (developing only) in 1995 to that in 2001?
Provide a short and direct response. 0.97. What is the ratio of the Aid flow from UN agencies (US$) in Upper middle income in 1995 to that in 2001?
Provide a succinct answer. 0.94. What is the ratio of the Aid flow from UN agencies (US$) of Lebanon in 1995 to that in 2001?
Give a very brief answer. 0.9. What is the ratio of the Aid flow from UN agencies (US$) in Syrian Arab Republic in 1995 to that in 2001?
Provide a short and direct response. 1.2. What is the ratio of the Aid flow from UN agencies (US$) of Middle East & North Africa (developing only) in 1996 to that in 1997?
Your answer should be compact. 0.9. What is the ratio of the Aid flow from UN agencies (US$) in Upper middle income in 1996 to that in 1997?
Ensure brevity in your answer.  0.84. What is the ratio of the Aid flow from UN agencies (US$) in Lebanon in 1996 to that in 1997?
Your answer should be compact. 0.84. What is the ratio of the Aid flow from UN agencies (US$) in Syrian Arab Republic in 1996 to that in 1997?
Make the answer very short. 0.92. What is the ratio of the Aid flow from UN agencies (US$) in Middle East & North Africa (developing only) in 1996 to that in 1998?
Your answer should be very brief. 0.79. What is the ratio of the Aid flow from UN agencies (US$) in Upper middle income in 1996 to that in 1998?
Keep it short and to the point. 0.81. What is the ratio of the Aid flow from UN agencies (US$) of Lebanon in 1996 to that in 1998?
Give a very brief answer. 0.73. What is the ratio of the Aid flow from UN agencies (US$) in Syrian Arab Republic in 1996 to that in 1998?
Make the answer very short. 0.91. What is the ratio of the Aid flow from UN agencies (US$) of Middle East & North Africa (developing only) in 1996 to that in 1999?
Keep it short and to the point. 0.83. What is the ratio of the Aid flow from UN agencies (US$) of Upper middle income in 1996 to that in 1999?
Give a very brief answer. 0.79. What is the ratio of the Aid flow from UN agencies (US$) in Lebanon in 1996 to that in 1999?
Your answer should be compact. 0.8. What is the ratio of the Aid flow from UN agencies (US$) in Middle East & North Africa (developing only) in 1996 to that in 2000?
Offer a very short reply. 0.79. What is the ratio of the Aid flow from UN agencies (US$) in Upper middle income in 1996 to that in 2000?
Offer a terse response. 0.79. What is the ratio of the Aid flow from UN agencies (US$) in Lebanon in 1996 to that in 2000?
Offer a very short reply. 0.73. What is the ratio of the Aid flow from UN agencies (US$) in Syrian Arab Republic in 1996 to that in 2000?
Offer a terse response. 0.84. What is the ratio of the Aid flow from UN agencies (US$) of Middle East & North Africa (developing only) in 1996 to that in 2001?
Offer a very short reply. 0.66. What is the ratio of the Aid flow from UN agencies (US$) of Upper middle income in 1996 to that in 2001?
Provide a succinct answer. 0.79. What is the ratio of the Aid flow from UN agencies (US$) in Lebanon in 1996 to that in 2001?
Your response must be concise. 0.73. What is the ratio of the Aid flow from UN agencies (US$) of Syrian Arab Republic in 1996 to that in 2001?
Your response must be concise. 0.88. What is the ratio of the Aid flow from UN agencies (US$) in Middle East & North Africa (developing only) in 1997 to that in 1998?
Your response must be concise. 0.88. What is the ratio of the Aid flow from UN agencies (US$) of Upper middle income in 1997 to that in 1998?
Your answer should be very brief. 0.96. What is the ratio of the Aid flow from UN agencies (US$) of Lebanon in 1997 to that in 1998?
Provide a short and direct response. 0.87. What is the ratio of the Aid flow from UN agencies (US$) of Syrian Arab Republic in 1997 to that in 1998?
Offer a terse response. 0.99. What is the ratio of the Aid flow from UN agencies (US$) of Middle East & North Africa (developing only) in 1997 to that in 1999?
Offer a very short reply. 0.92. What is the ratio of the Aid flow from UN agencies (US$) in Upper middle income in 1997 to that in 1999?
Keep it short and to the point. 0.93. What is the ratio of the Aid flow from UN agencies (US$) in Lebanon in 1997 to that in 1999?
Ensure brevity in your answer.  0.95. What is the ratio of the Aid flow from UN agencies (US$) in Syrian Arab Republic in 1997 to that in 1999?
Give a very brief answer. 1.09. What is the ratio of the Aid flow from UN agencies (US$) in Middle East & North Africa (developing only) in 1997 to that in 2000?
Provide a succinct answer. 0.88. What is the ratio of the Aid flow from UN agencies (US$) in Upper middle income in 1997 to that in 2000?
Your answer should be very brief. 0.93. What is the ratio of the Aid flow from UN agencies (US$) of Lebanon in 1997 to that in 2000?
Offer a very short reply. 0.87. What is the ratio of the Aid flow from UN agencies (US$) of Syrian Arab Republic in 1997 to that in 2000?
Ensure brevity in your answer.  0.91. What is the ratio of the Aid flow from UN agencies (US$) in Middle East & North Africa (developing only) in 1997 to that in 2001?
Offer a very short reply. 0.73. What is the ratio of the Aid flow from UN agencies (US$) in Upper middle income in 1997 to that in 2001?
Ensure brevity in your answer.  0.93. What is the ratio of the Aid flow from UN agencies (US$) in Lebanon in 1997 to that in 2001?
Keep it short and to the point. 0.88. What is the ratio of the Aid flow from UN agencies (US$) of Syrian Arab Republic in 1997 to that in 2001?
Keep it short and to the point. 0.95. What is the ratio of the Aid flow from UN agencies (US$) of Middle East & North Africa (developing only) in 1998 to that in 1999?
Your answer should be compact. 1.04. What is the ratio of the Aid flow from UN agencies (US$) of Upper middle income in 1998 to that in 1999?
Make the answer very short. 0.98. What is the ratio of the Aid flow from UN agencies (US$) in Lebanon in 1998 to that in 1999?
Give a very brief answer. 1.09. What is the ratio of the Aid flow from UN agencies (US$) in Syrian Arab Republic in 1998 to that in 1999?
Keep it short and to the point. 1.11. What is the ratio of the Aid flow from UN agencies (US$) in Upper middle income in 1998 to that in 2000?
Offer a terse response. 0.97. What is the ratio of the Aid flow from UN agencies (US$) of Lebanon in 1998 to that in 2000?
Keep it short and to the point. 1. What is the ratio of the Aid flow from UN agencies (US$) of Syrian Arab Republic in 1998 to that in 2000?
Keep it short and to the point. 0.93. What is the ratio of the Aid flow from UN agencies (US$) in Middle East & North Africa (developing only) in 1998 to that in 2001?
Make the answer very short. 0.83. What is the ratio of the Aid flow from UN agencies (US$) of Upper middle income in 1998 to that in 2001?
Give a very brief answer. 0.97. What is the ratio of the Aid flow from UN agencies (US$) in Syrian Arab Republic in 1998 to that in 2001?
Provide a short and direct response. 0.96. What is the ratio of the Aid flow from UN agencies (US$) in Middle East & North Africa (developing only) in 1999 to that in 2000?
Offer a terse response. 0.95. What is the ratio of the Aid flow from UN agencies (US$) of Upper middle income in 1999 to that in 2000?
Your response must be concise. 1. What is the ratio of the Aid flow from UN agencies (US$) in Lebanon in 1999 to that in 2000?
Your answer should be very brief. 0.91. What is the ratio of the Aid flow from UN agencies (US$) in Syrian Arab Republic in 1999 to that in 2000?
Give a very brief answer. 0.84. What is the ratio of the Aid flow from UN agencies (US$) of Middle East & North Africa (developing only) in 1999 to that in 2001?
Your response must be concise. 0.8. What is the ratio of the Aid flow from UN agencies (US$) of Lebanon in 1999 to that in 2001?
Offer a very short reply. 0.92. What is the ratio of the Aid flow from UN agencies (US$) in Syrian Arab Republic in 1999 to that in 2001?
Keep it short and to the point. 0.87. What is the ratio of the Aid flow from UN agencies (US$) in Middle East & North Africa (developing only) in 2000 to that in 2001?
Keep it short and to the point. 0.84. What is the ratio of the Aid flow from UN agencies (US$) in Syrian Arab Republic in 2000 to that in 2001?
Provide a short and direct response. 1.04. What is the difference between the highest and the second highest Aid flow from UN agencies (US$) of Middle East & North Africa (developing only)?
Your answer should be compact. 1.10e+07. What is the difference between the highest and the second highest Aid flow from UN agencies (US$) of Upper middle income?
Your response must be concise. 9.00e+04. What is the difference between the highest and the second highest Aid flow from UN agencies (US$) of Lebanon?
Keep it short and to the point. 2.10e+05. What is the difference between the highest and the second highest Aid flow from UN agencies (US$) in Syrian Arab Republic?
Your answer should be very brief. 3.43e+06. What is the difference between the highest and the lowest Aid flow from UN agencies (US$) of Middle East & North Africa (developing only)?
Give a very brief answer. 1.23e+08. What is the difference between the highest and the lowest Aid flow from UN agencies (US$) of Upper middle income?
Keep it short and to the point. 2.71e+07. What is the difference between the highest and the lowest Aid flow from UN agencies (US$) in Lebanon?
Offer a very short reply. 1.29e+07. What is the difference between the highest and the lowest Aid flow from UN agencies (US$) in Syrian Arab Republic?
Give a very brief answer. 7.11e+06. 